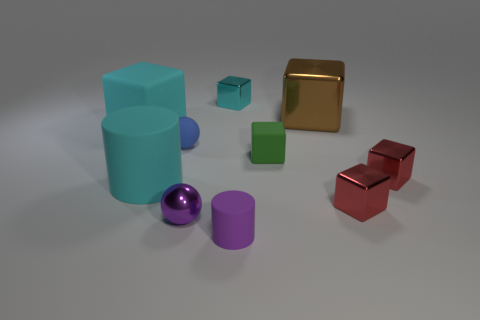Subtract all cyan balls. How many red cubes are left? 2 Subtract all cyan rubber blocks. How many blocks are left? 5 Subtract all brown blocks. How many blocks are left? 5 Subtract all green blocks. Subtract all yellow spheres. How many blocks are left? 5 Subtract 0 yellow balls. How many objects are left? 10 Subtract all balls. How many objects are left? 8 Subtract all small red shiny blocks. Subtract all cubes. How many objects are left? 2 Add 5 big metal cubes. How many big metal cubes are left? 6 Add 4 spheres. How many spheres exist? 6 